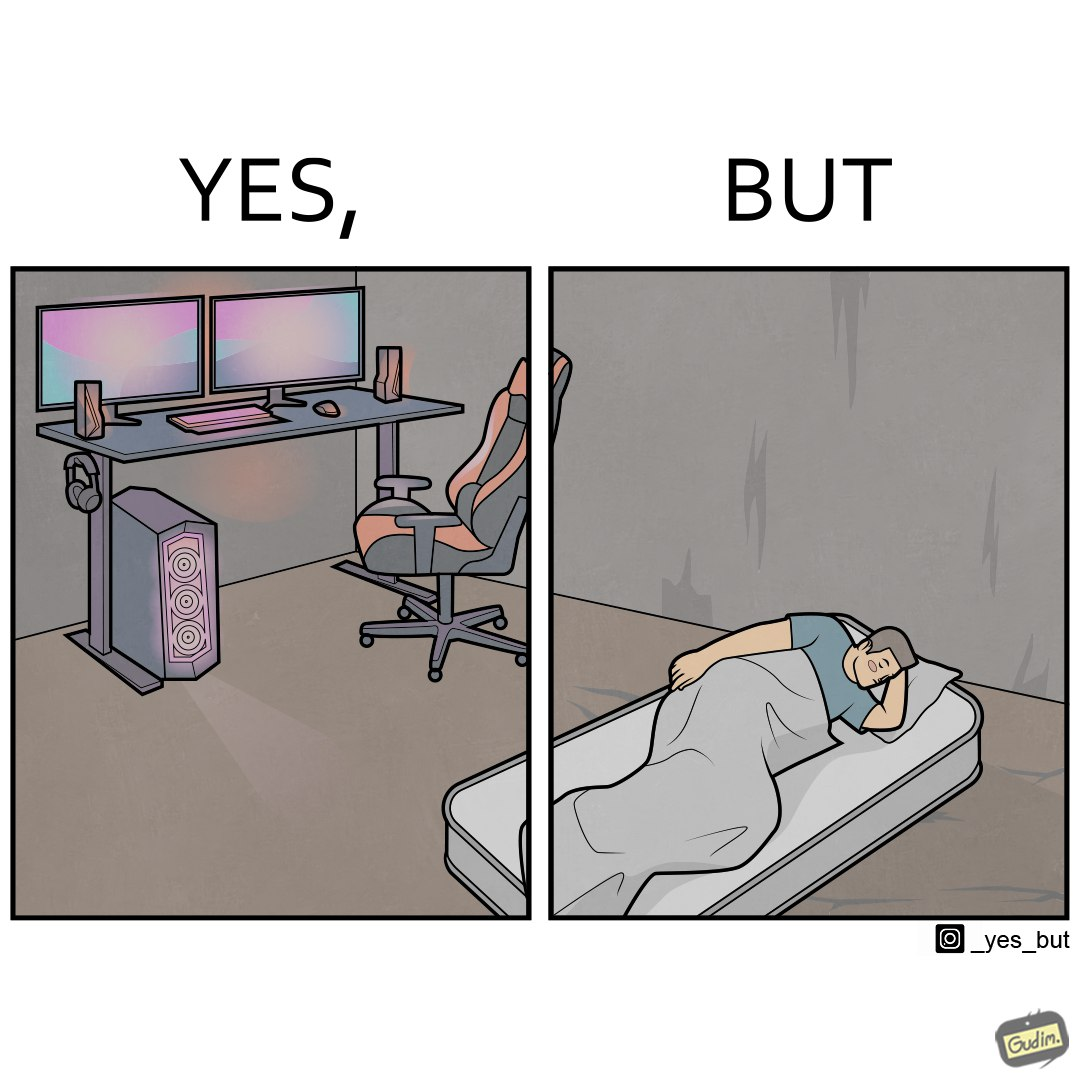Describe what you see in the left and right parts of this image. In the left part of the image: The image shows a computer desk with two monitors, two speakers on the side, a headphone hanging off the side of the table, a cpu on the floor with lights glowing on the front of the cpu and a very comfortable looking gaming chair. The whole setup looks high end and expensive. In the right part of the image: The image shows a man sleeping on a mattress on the floor. There does not seem to be a bedsheet on the mattress. 